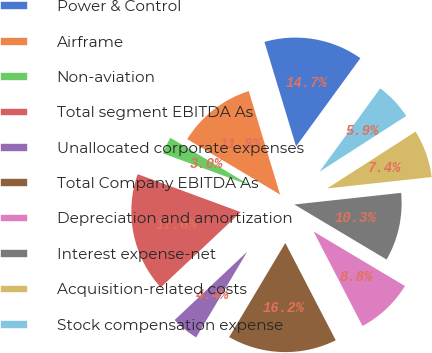Convert chart to OTSL. <chart><loc_0><loc_0><loc_500><loc_500><pie_chart><fcel>Power & Control<fcel>Airframe<fcel>Non-aviation<fcel>Total segment EBITDA As<fcel>Unallocated corporate expenses<fcel>Total Company EBITDA As<fcel>Depreciation and amortization<fcel>Interest expense-net<fcel>Acquisition-related costs<fcel>Stock compensation expense<nl><fcel>14.7%<fcel>11.76%<fcel>2.95%<fcel>17.63%<fcel>4.42%<fcel>16.17%<fcel>8.83%<fcel>10.29%<fcel>7.36%<fcel>5.89%<nl></chart> 